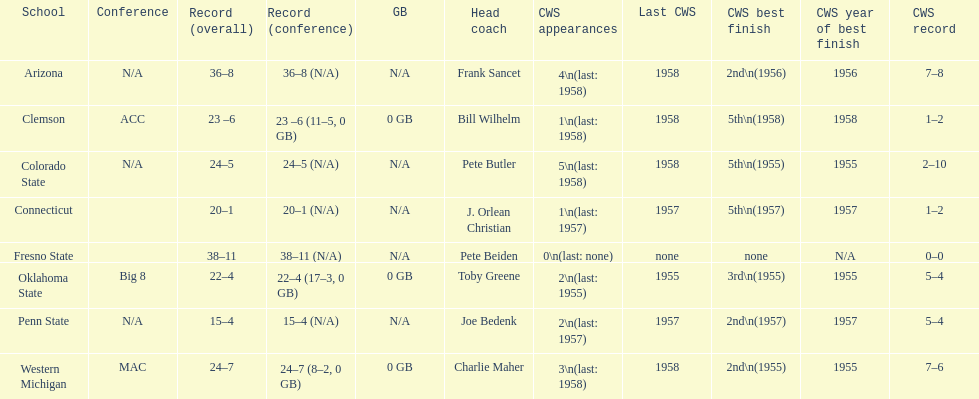Which teams played in the 1959 ncaa university division baseball tournament? Arizona, Clemson, Colorado State, Connecticut, Fresno State, Oklahoma State, Penn State, Western Michigan. Which was the only one to win less than 20 games? Penn State. 